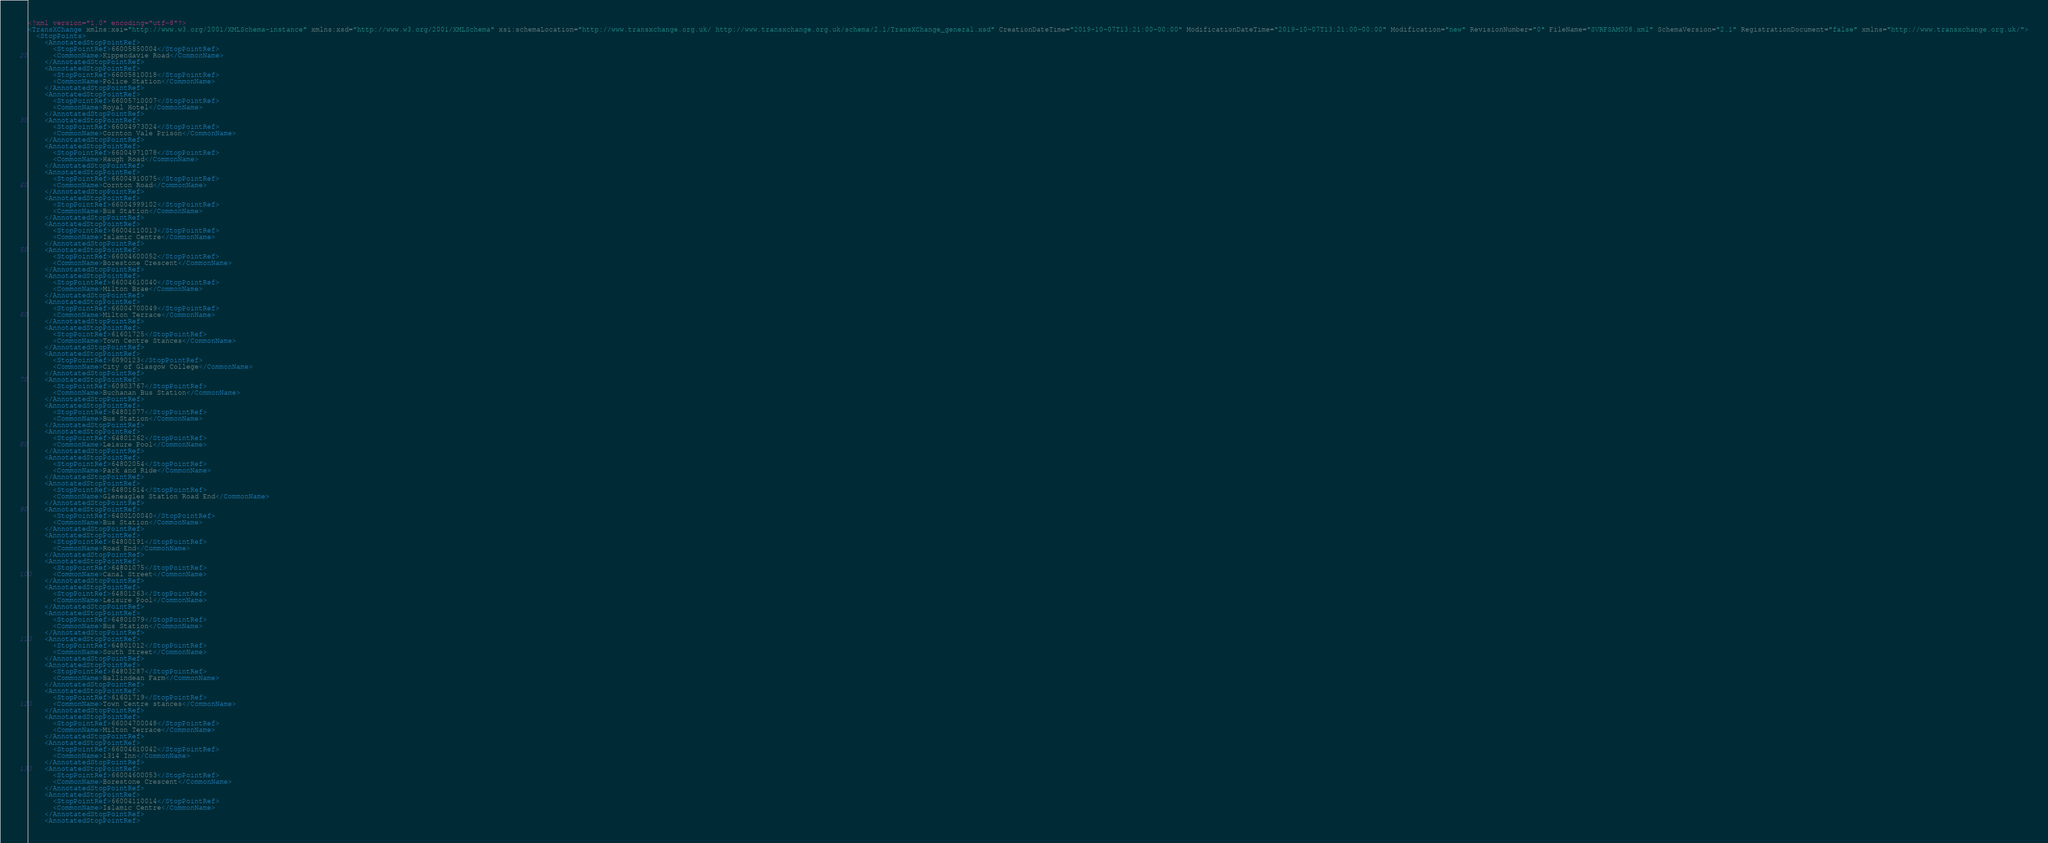<code> <loc_0><loc_0><loc_500><loc_500><_XML_><?xml version="1.0" encoding="utf-8"?>
<TransXChange xmlns:xsi="http://www.w3.org/2001/XMLSchema-instance" xmlns:xsd="http://www.w3.org/2001/XMLSchema" xsi:schemaLocation="http://www.transxchange.org.uk/ http://www.transxchange.org.uk/schema/2.1/TransXChange_general.xsd" CreationDateTime="2019-10-07T13:21:00-00:00" ModificationDateTime="2019-10-07T13:21:00-00:00" Modification="new" RevisionNumber="0" FileName="SVRFSAM008.xml" SchemaVersion="2.1" RegistrationDocument="false" xmlns="http://www.transxchange.org.uk/">
  <StopPoints>
    <AnnotatedStopPointRef>
      <StopPointRef>66005850004</StopPointRef>
      <CommonName>Kippendavie Road</CommonName>
    </AnnotatedStopPointRef>
    <AnnotatedStopPointRef>
      <StopPointRef>66005810018</StopPointRef>
      <CommonName>Police Station</CommonName>
    </AnnotatedStopPointRef>
    <AnnotatedStopPointRef>
      <StopPointRef>66005710007</StopPointRef>
      <CommonName>Royal Hotel</CommonName>
    </AnnotatedStopPointRef>
    <AnnotatedStopPointRef>
      <StopPointRef>66004973024</StopPointRef>
      <CommonName>Cornton Vale Prison</CommonName>
    </AnnotatedStopPointRef>
    <AnnotatedStopPointRef>
      <StopPointRef>66004971078</StopPointRef>
      <CommonName>Haugh Road</CommonName>
    </AnnotatedStopPointRef>
    <AnnotatedStopPointRef>
      <StopPointRef>66004910075</StopPointRef>
      <CommonName>Cornton Road</CommonName>
    </AnnotatedStopPointRef>
    <AnnotatedStopPointRef>
      <StopPointRef>66004999102</StopPointRef>
      <CommonName>Bus Station</CommonName>
    </AnnotatedStopPointRef>
    <AnnotatedStopPointRef>
      <StopPointRef>66004110013</StopPointRef>
      <CommonName>Islamic Centre</CommonName>
    </AnnotatedStopPointRef>
    <AnnotatedStopPointRef>
      <StopPointRef>66004600052</StopPointRef>
      <CommonName>Borestone Crescent</CommonName>
    </AnnotatedStopPointRef>
    <AnnotatedStopPointRef>
      <StopPointRef>66004610040</StopPointRef>
      <CommonName>Milton Brae</CommonName>
    </AnnotatedStopPointRef>
    <AnnotatedStopPointRef>
      <StopPointRef>66004700049</StopPointRef>
      <CommonName>Milton Terrace</CommonName>
    </AnnotatedStopPointRef>
    <AnnotatedStopPointRef>
      <StopPointRef>61601725</StopPointRef>
      <CommonName>Town Centre Stances</CommonName>
    </AnnotatedStopPointRef>
    <AnnotatedStopPointRef>
      <StopPointRef>6090123</StopPointRef>
      <CommonName>City of Glasgow College</CommonName>
    </AnnotatedStopPointRef>
    <AnnotatedStopPointRef>
      <StopPointRef>60903767</StopPointRef>
      <CommonName>Buchanan Bus Station</CommonName>
    </AnnotatedStopPointRef>
    <AnnotatedStopPointRef>
      <StopPointRef>64801077</StopPointRef>
      <CommonName>Bus Station</CommonName>
    </AnnotatedStopPointRef>
    <AnnotatedStopPointRef>
      <StopPointRef>64801262</StopPointRef>
      <CommonName>Leisure Pool</CommonName>
    </AnnotatedStopPointRef>
    <AnnotatedStopPointRef>
      <StopPointRef>64802054</StopPointRef>
      <CommonName>Park and Ride</CommonName>
    </AnnotatedStopPointRef>
    <AnnotatedStopPointRef>
      <StopPointRef>64801614</StopPointRef>
      <CommonName>Gleneagles Station Road End</CommonName>
    </AnnotatedStopPointRef>
    <AnnotatedStopPointRef>
      <StopPointRef>6400L00040</StopPointRef>
      <CommonName>Bus Station</CommonName>
    </AnnotatedStopPointRef>
    <AnnotatedStopPointRef>
      <StopPointRef>64800191</StopPointRef>
      <CommonName>Road End</CommonName>
    </AnnotatedStopPointRef>
    <AnnotatedStopPointRef>
      <StopPointRef>64801075</StopPointRef>
      <CommonName>Canal Street</CommonName>
    </AnnotatedStopPointRef>
    <AnnotatedStopPointRef>
      <StopPointRef>64801263</StopPointRef>
      <CommonName>Leisure Pool</CommonName>
    </AnnotatedStopPointRef>
    <AnnotatedStopPointRef>
      <StopPointRef>64801079</StopPointRef>
      <CommonName>Bus Station</CommonName>
    </AnnotatedStopPointRef>
    <AnnotatedStopPointRef>
      <StopPointRef>64801012</StopPointRef>
      <CommonName>South Street</CommonName>
    </AnnotatedStopPointRef>
    <AnnotatedStopPointRef>
      <StopPointRef>64803287</StopPointRef>
      <CommonName>Ballindean Farm</CommonName>
    </AnnotatedStopPointRef>
    <AnnotatedStopPointRef>
      <StopPointRef>61601719</StopPointRef>
      <CommonName>Town Centre stances</CommonName>
    </AnnotatedStopPointRef>
    <AnnotatedStopPointRef>
      <StopPointRef>66004700048</StopPointRef>
      <CommonName>Milton Terrace</CommonName>
    </AnnotatedStopPointRef>
    <AnnotatedStopPointRef>
      <StopPointRef>66004610042</StopPointRef>
      <CommonName>1314 Inn</CommonName>
    </AnnotatedStopPointRef>
    <AnnotatedStopPointRef>
      <StopPointRef>66004600053</StopPointRef>
      <CommonName>Borestone Crescent</CommonName>
    </AnnotatedStopPointRef>
    <AnnotatedStopPointRef>
      <StopPointRef>66004110014</StopPointRef>
      <CommonName>Islamic Centre</CommonName>
    </AnnotatedStopPointRef>
    <AnnotatedStopPointRef></code> 